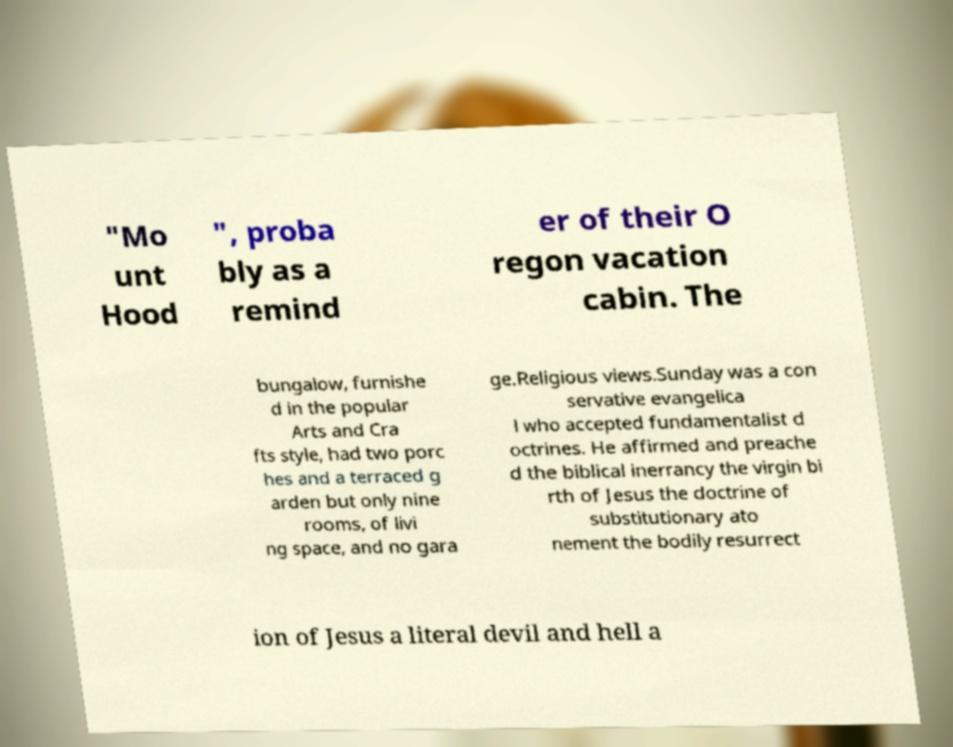Please read and relay the text visible in this image. What does it say? "Mo unt Hood ", proba bly as a remind er of their O regon vacation cabin. The bungalow, furnishe d in the popular Arts and Cra fts style, had two porc hes and a terraced g arden but only nine rooms, of livi ng space, and no gara ge.Religious views.Sunday was a con servative evangelica l who accepted fundamentalist d octrines. He affirmed and preache d the biblical inerrancy the virgin bi rth of Jesus the doctrine of substitutionary ato nement the bodily resurrect ion of Jesus a literal devil and hell a 